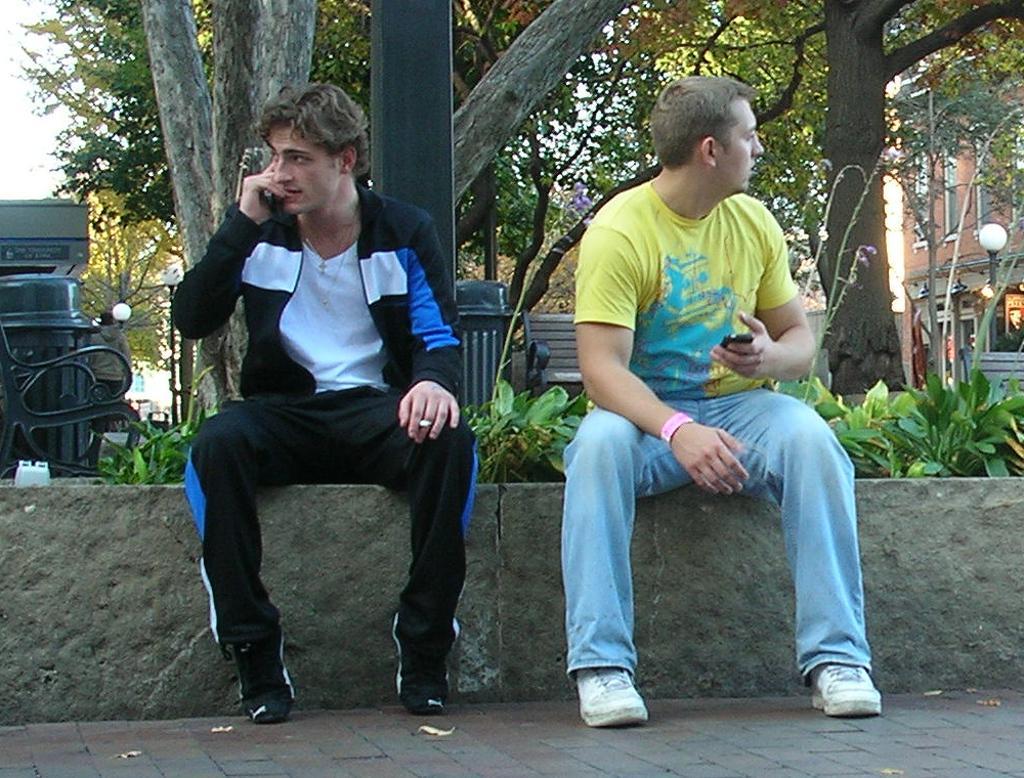In one or two sentences, can you explain what this image depicts? In the image we can see two persons were sitting on the stone. And back we can see trees,buildings,street light,plants,dustbin,sky etc. 